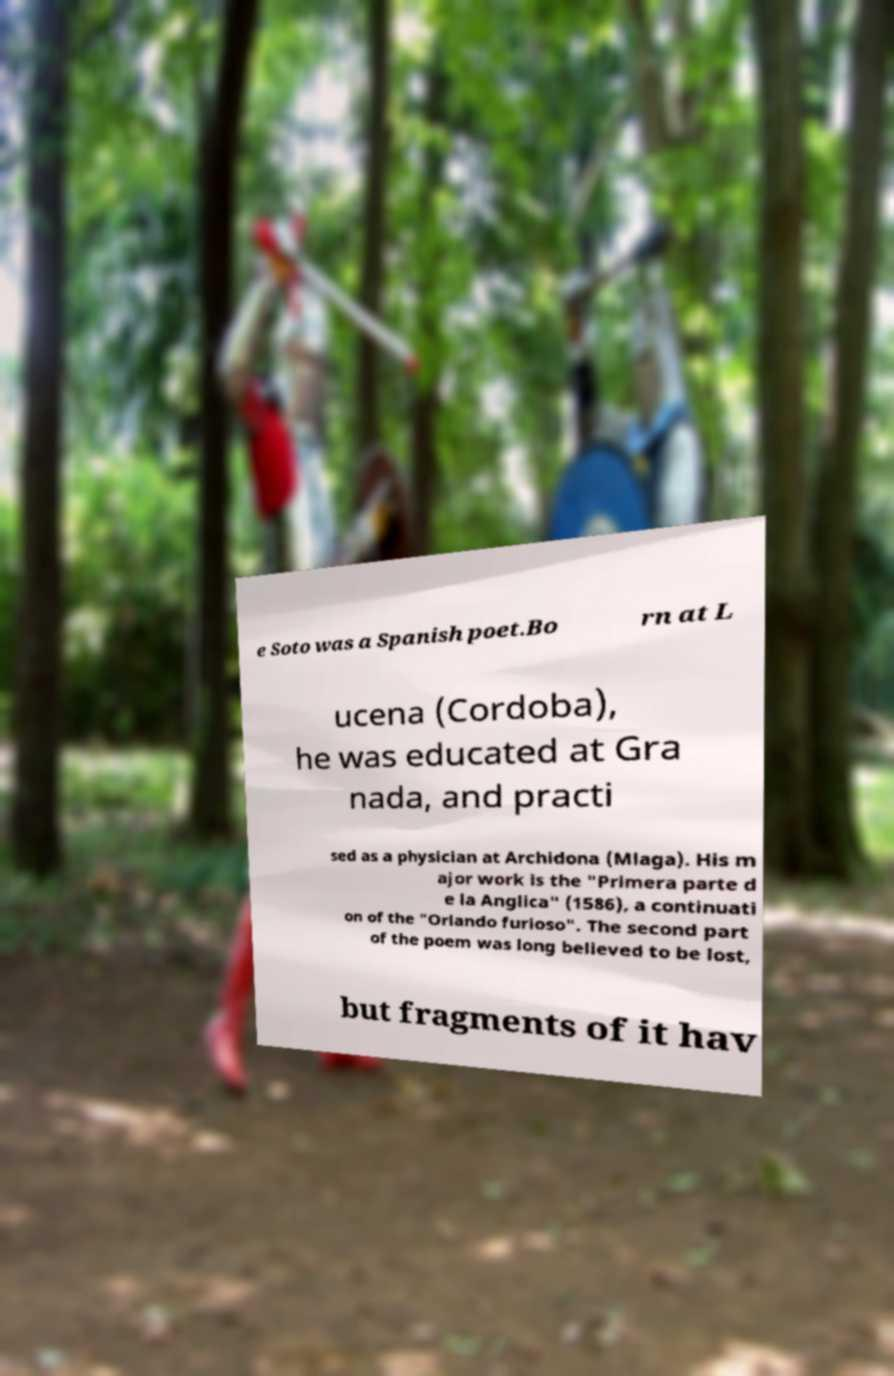What messages or text are displayed in this image? I need them in a readable, typed format. e Soto was a Spanish poet.Bo rn at L ucena (Cordoba), he was educated at Gra nada, and practi sed as a physician at Archidona (Mlaga). His m ajor work is the "Primera parte d e la Anglica" (1586), a continuati on of the "Orlando furioso". The second part of the poem was long believed to be lost, but fragments of it hav 